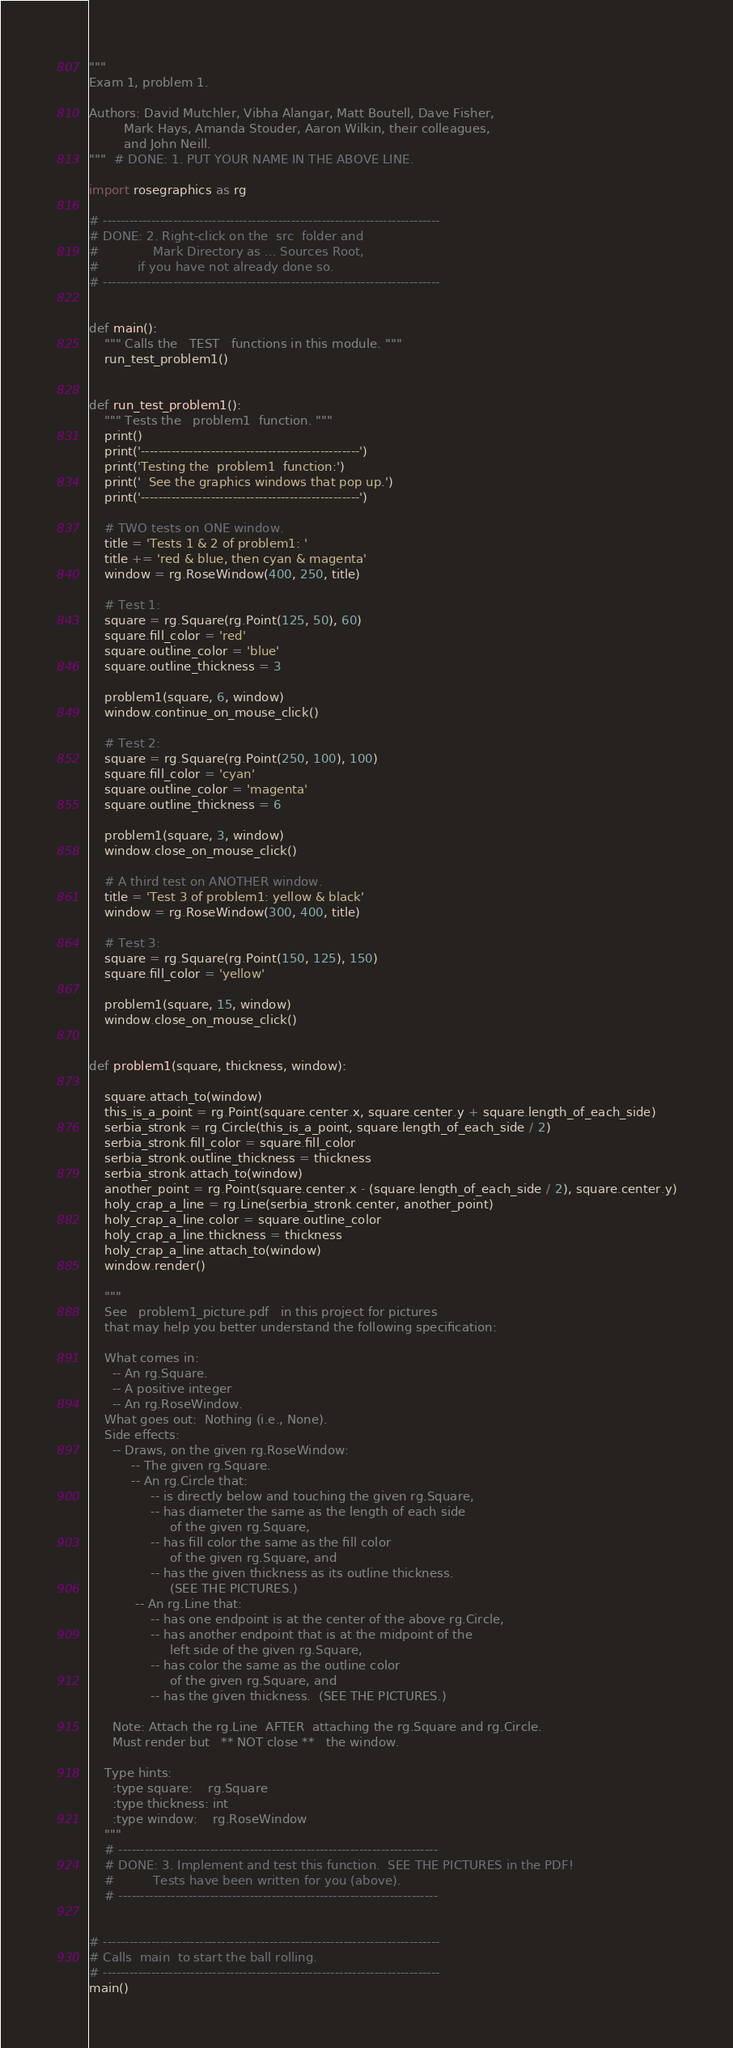<code> <loc_0><loc_0><loc_500><loc_500><_Python_>"""
Exam 1, problem 1.

Authors: David Mutchler, Vibha Alangar, Matt Boutell, Dave Fisher,
         Mark Hays, Amanda Stouder, Aaron Wilkin, their colleagues,
         and John Neill.
"""  # DONE: 1. PUT YOUR NAME IN THE ABOVE LINE.

import rosegraphics as rg

# -----------------------------------------------------------------------------
# DONE: 2. Right-click on the  src  folder and
#              Mark Directory as ... Sources Root,
#          if you have not already done so.
# -----------------------------------------------------------------------------


def main():
    """ Calls the   TEST   functions in this module. """
    run_test_problem1()


def run_test_problem1():
    """ Tests the   problem1  function. """
    print()
    print('--------------------------------------------------')
    print('Testing the  problem1  function:')
    print('  See the graphics windows that pop up.')
    print('--------------------------------------------------')

    # TWO tests on ONE window.
    title = 'Tests 1 & 2 of problem1: '
    title += 'red & blue, then cyan & magenta'
    window = rg.RoseWindow(400, 250, title)

    # Test 1:
    square = rg.Square(rg.Point(125, 50), 60)
    square.fill_color = 'red'
    square.outline_color = 'blue'
    square.outline_thickness = 3

    problem1(square, 6, window)
    window.continue_on_mouse_click()

    # Test 2:
    square = rg.Square(rg.Point(250, 100), 100)
    square.fill_color = 'cyan'
    square.outline_color = 'magenta'
    square.outline_thickness = 6

    problem1(square, 3, window)
    window.close_on_mouse_click()

    # A third test on ANOTHER window.
    title = 'Test 3 of problem1: yellow & black'
    window = rg.RoseWindow(300, 400, title)

    # Test 3:
    square = rg.Square(rg.Point(150, 125), 150)
    square.fill_color = 'yellow'

    problem1(square, 15, window)
    window.close_on_mouse_click()


def problem1(square, thickness, window):

    square.attach_to(window)
    this_is_a_point = rg.Point(square.center.x, square.center.y + square.length_of_each_side)
    serbia_stronk = rg.Circle(this_is_a_point, square.length_of_each_side / 2)
    serbia_stronk.fill_color = square.fill_color
    serbia_stronk.outline_thickness = thickness
    serbia_stronk.attach_to(window)
    another_point = rg.Point(square.center.x - (square.length_of_each_side / 2), square.center.y)
    holy_crap_a_line = rg.Line(serbia_stronk.center, another_point)
    holy_crap_a_line.color = square.outline_color
    holy_crap_a_line.thickness = thickness
    holy_crap_a_line.attach_to(window)
    window.render()

    """
    See   problem1_picture.pdf   in this project for pictures
    that may help you better understand the following specification:

    What comes in:
      -- An rg.Square.
      -- A positive integer
      -- An rg.RoseWindow.
    What goes out:  Nothing (i.e., None).
    Side effects:
      -- Draws, on the given rg.RoseWindow:
           -- The given rg.Square.
           -- An rg.Circle that:
                -- is directly below and touching the given rg.Square,
                -- has diameter the same as the length of each side
                     of the given rg.Square,
                -- has fill color the same as the fill color
                     of the given rg.Square, and
                -- has the given thickness as its outline thickness.
                     (SEE THE PICTURES.)
            -- An rg.Line that:
                -- has one endpoint is at the center of the above rg.Circle,
                -- has another endpoint that is at the midpoint of the
                     left side of the given rg.Square,
                -- has color the same as the outline color
                     of the given rg.Square, and
                -- has the given thickness.  (SEE THE PICTURES.)

      Note: Attach the rg.Line  AFTER  attaching the rg.Square and rg.Circle.
      Must render but   ** NOT close **   the window.

    Type hints:
      :type square:    rg.Square
      :type thickness: int
      :type window:    rg.RoseWindow
    """
    # -------------------------------------------------------------------------
    # DONE: 3. Implement and test this function.  SEE THE PICTURES in the PDF!
    #          Tests have been written for you (above).
    # -------------------------------------------------------------------------


# -----------------------------------------------------------------------------
# Calls  main  to start the ball rolling.
# -----------------------------------------------------------------------------
main()
</code> 